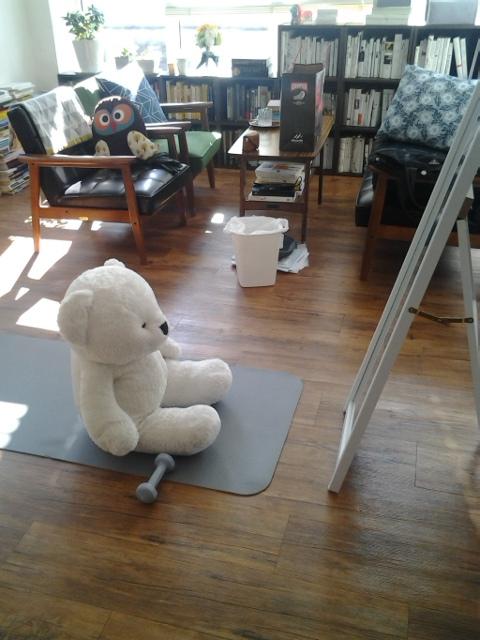What is the stuffed animal facing?
Be succinct. Mirror. How many stuffed animals are in the room?
Give a very brief answer. 2. How heavy is the dumbbell?
Write a very short answer. 1 lb. 